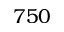Convert formula to latex. <formula><loc_0><loc_0><loc_500><loc_500>7 5 0</formula> 